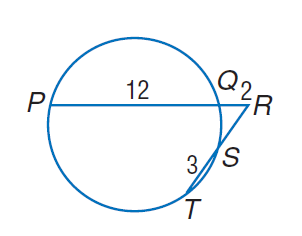Answer the mathemtical geometry problem and directly provide the correct option letter.
Question: Find R S if P Q = 12, Q R = 2, and T S = 3.
Choices: A: 2 B: 3 C: 4 D: 12 C 